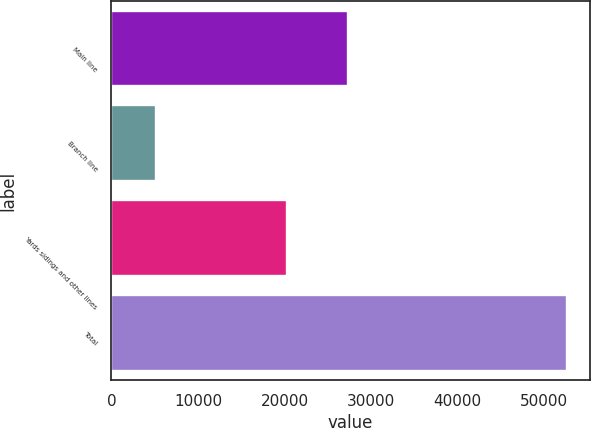Convert chart. <chart><loc_0><loc_0><loc_500><loc_500><bar_chart><fcel>Main line<fcel>Branch line<fcel>Yards sidings and other lines<fcel>Total<nl><fcel>27301<fcel>5125<fcel>20241<fcel>52667<nl></chart> 